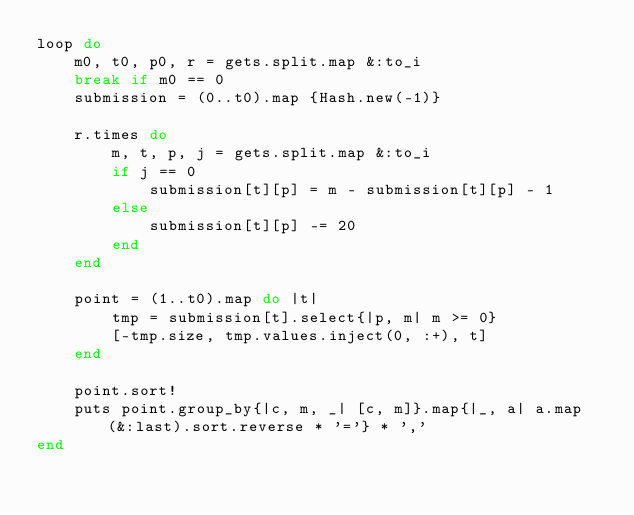<code> <loc_0><loc_0><loc_500><loc_500><_Ruby_>loop do
    m0, t0, p0, r = gets.split.map &:to_i
    break if m0 == 0
    submission = (0..t0).map {Hash.new(-1)}

    r.times do
        m, t, p, j = gets.split.map &:to_i
        if j == 0
            submission[t][p] = m - submission[t][p] - 1 
        else
            submission[t][p] -= 20
        end
    end 
    
    point = (1..t0).map do |t| 
        tmp = submission[t].select{|p, m| m >= 0}
        [-tmp.size, tmp.values.inject(0, :+), t]
    end 

    point.sort!
    puts point.group_by{|c, m, _| [c, m]}.map{|_, a| a.map(&:last).sort.reverse * '='} * ',' 
end</code> 